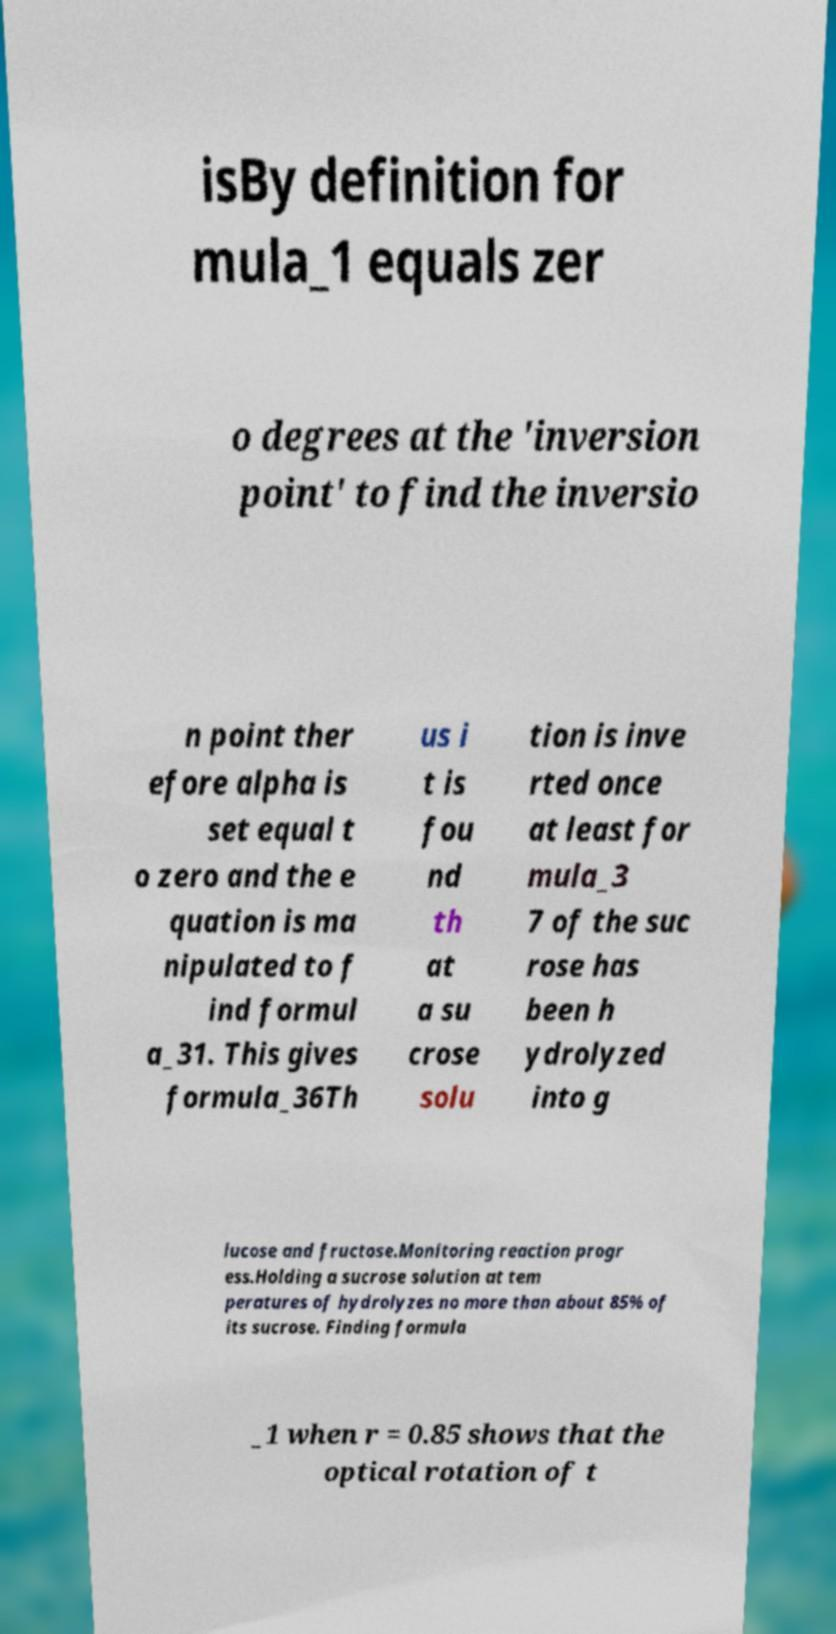Please read and relay the text visible in this image. What does it say? isBy definition for mula_1 equals zer o degrees at the 'inversion point' to find the inversio n point ther efore alpha is set equal t o zero and the e quation is ma nipulated to f ind formul a_31. This gives formula_36Th us i t is fou nd th at a su crose solu tion is inve rted once at least for mula_3 7 of the suc rose has been h ydrolyzed into g lucose and fructose.Monitoring reaction progr ess.Holding a sucrose solution at tem peratures of hydrolyzes no more than about 85% of its sucrose. Finding formula _1 when r = 0.85 shows that the optical rotation of t 